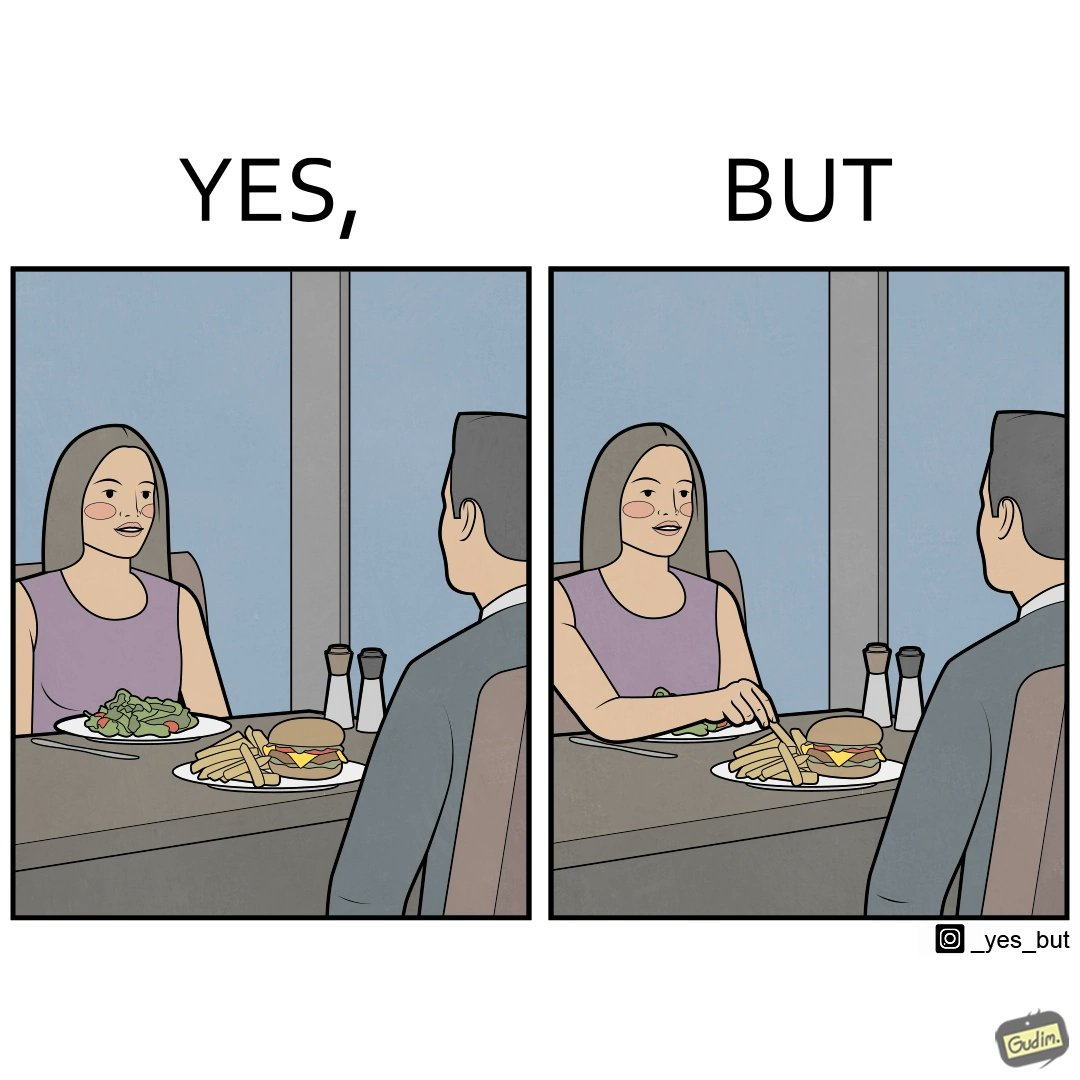Is this a satirical image? Yes, this image is satirical. 